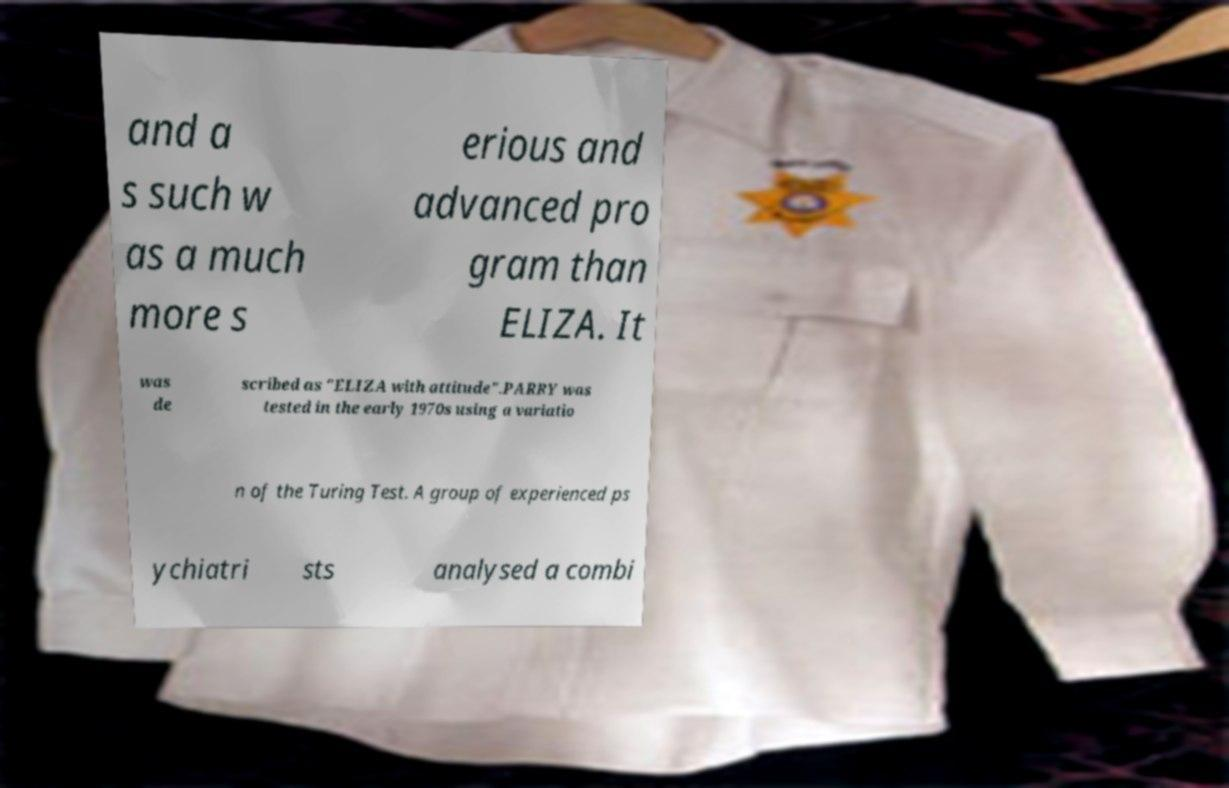There's text embedded in this image that I need extracted. Can you transcribe it verbatim? and a s such w as a much more s erious and advanced pro gram than ELIZA. It was de scribed as "ELIZA with attitude".PARRY was tested in the early 1970s using a variatio n of the Turing Test. A group of experienced ps ychiatri sts analysed a combi 